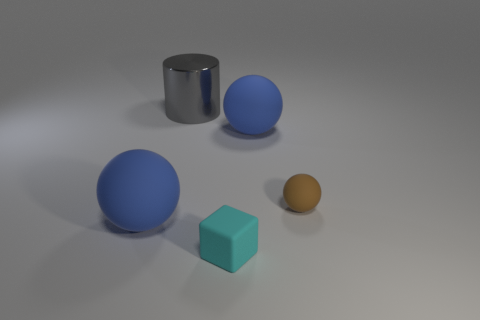There is a tiny cyan cube that is on the left side of the large matte object that is behind the tiny brown rubber thing; how many things are to the right of it? To the right of the tiny cyan cube, there are two objects: a large blue sphere and a small brown sphere. These items are arranged with ample space between them on a smooth surface, which appears to be part of a simple scene designed to showcase these geometric shapes. 